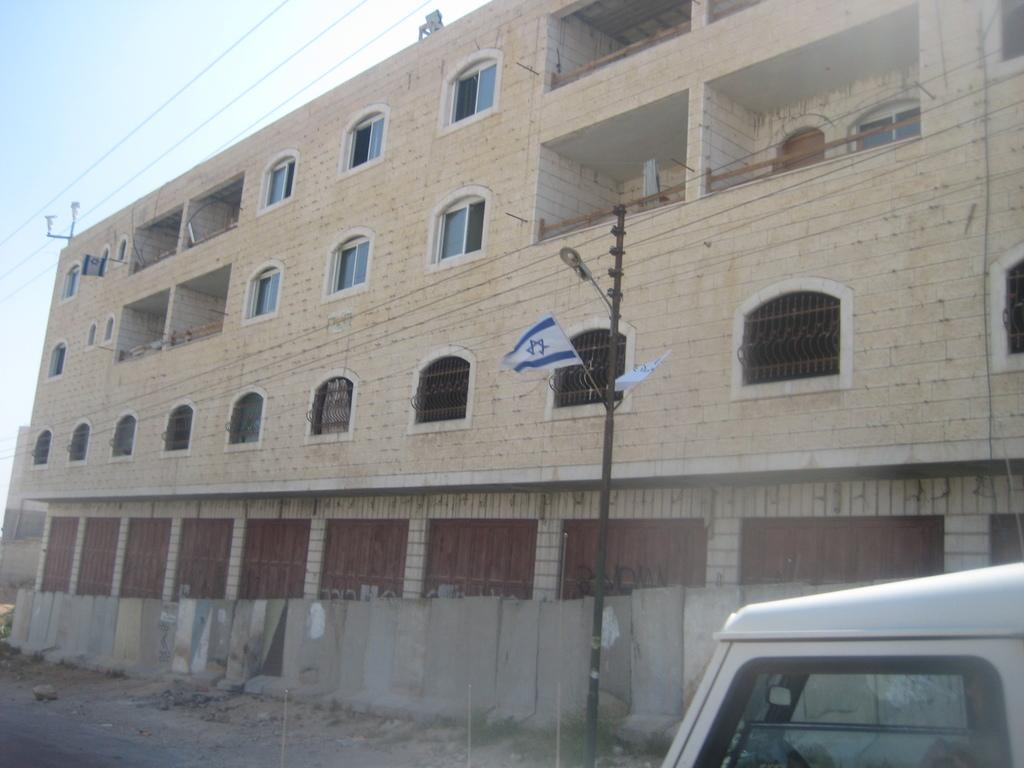What type of structure is visible in the image? There is a building in the image. What is located in the center of the image? There is a pole in the center of the image. What type of vehicle is at the bottom side of the image? There is a car at the bottom side of the image. What type of lipstick is the car applying in the image? There is no lipstick or car applying lipstick present in the image. Are there any mice visible in the image? There are no mice present in the image. 